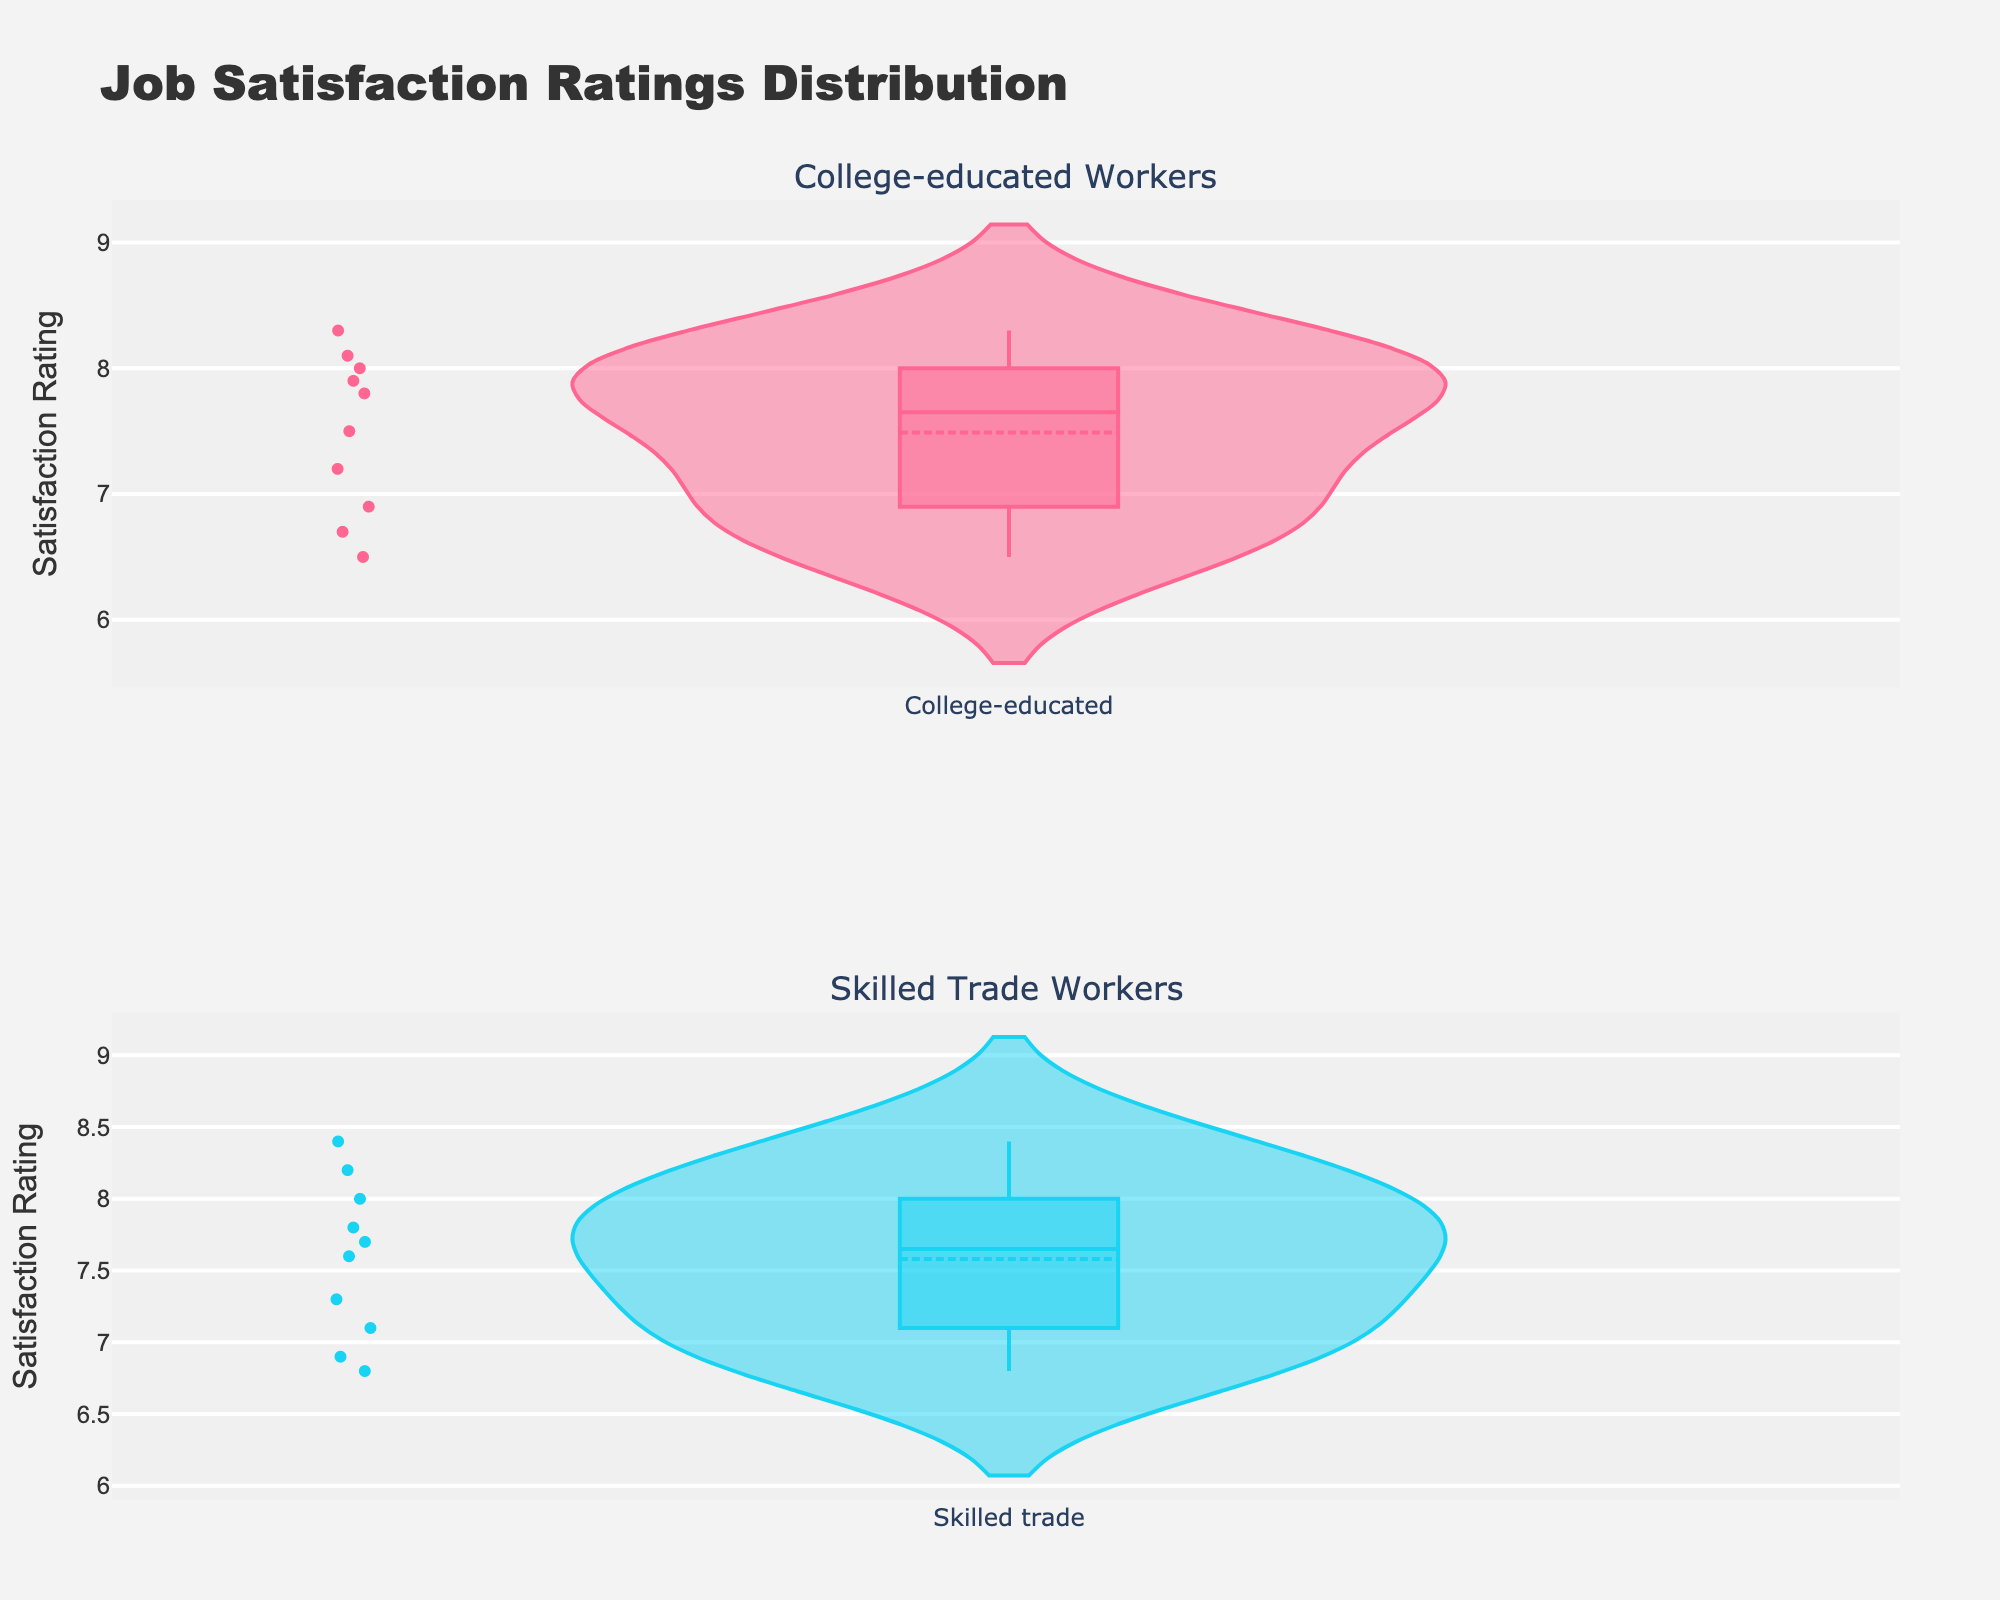What's the title of the figure? The title of the figure is usually located at the top-center of the plot. It provides a summary of what the figure is about. Here, it reads "Job Satisfaction Ratings Distribution."
Answer: Job Satisfaction Ratings Distribution How many subplots are in the figure? The figure is divided into two parts, each representing a different category of workers. You can tell there are two subplots because the titles "College-educated Workers" and "Skilled Trade Workers" are displayed above each row.
Answer: Two What is the y-axis label? The y-axis label for a plot typically describes the variable being measured along that axis. Here, the y-axis label reads "Satisfaction Rating," indicating that the plots show job satisfaction ratings.
Answer: Satisfaction Rating Which group's satisfaction ratings have a wider range? To determine this, observe the spread of the ratings for each group. The College-educated workers’ ratings range approximately from 6.5 to 8.3, while the Skilled trade workers’ ratings range approximately from 6.8 to 8.4. So, the range is slightly wider for Skilled trade workers.
Answer: Skilled trade workers Which group has the higher median satisfaction rating? Look for the white points or lines in the middle of the violin plots indicating the median. The median is slightly higher in the College-educated plot compared to the Skilled trade plot.
Answer: College-educated workers What is the approximate median satisfaction rating for the College-educated workers? The white line in the middle of the College-educated workers' violin plot represents the median. It looks like it's around 7.8.
Answer: 7.8 Which group has a higher mean satisfaction rating? The mean is indicated by the dashed line on the violin plots. By visual inspection, the mean for College-educated workers seems slightly lower than that for Skilled trade workers, which aligns around 7.5 for College-educated and around 7.7 for Skilled trade.
Answer: Skilled trade workers What range of satisfaction ratings do most College-educated workers fall into? The density of the violin plot indicates where most data points are concentrated. For College-educated workers, most points cluster between around 7.0 and 8.1.
Answer: 7.0 to 8.1 Is the data distribution more uniform for College-educated or Skilled trade workers? Uniform distribution implies equal spread along the range of ratings. The College-educated plot has more prominent peaks and troughs, suggesting less uniformity, whereas the Skilled trade plot appears more evenly spread out.
Answer: Skilled trade workers Are there any outliers in the satisfaction ratings for either group? Outliers are data points that deviate markedly from other observations. In violin plots, these are usually visible as points outside the central mass of the data. In both plots, there don't appear to be significant outliers.
Answer: No 